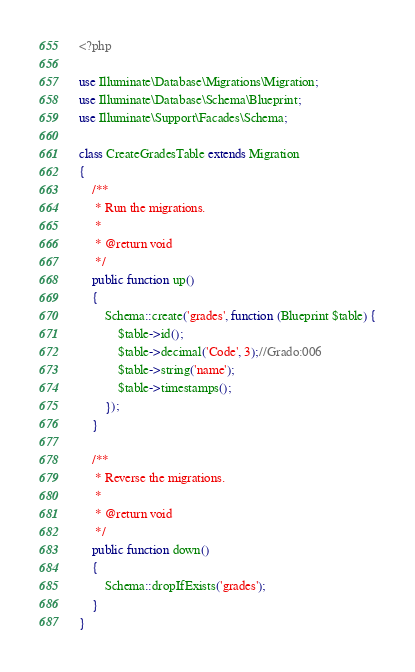Convert code to text. <code><loc_0><loc_0><loc_500><loc_500><_PHP_><?php

use Illuminate\Database\Migrations\Migration;
use Illuminate\Database\Schema\Blueprint;
use Illuminate\Support\Facades\Schema;

class CreateGradesTable extends Migration
{
    /**
     * Run the migrations.
     *
     * @return void
     */
    public function up()
    {
        Schema::create('grades', function (Blueprint $table) {
            $table->id();
            $table->decimal('Code', 3);//Grado:006
            $table->string('name');            
            $table->timestamps();
        });
    }

    /**
     * Reverse the migrations.
     *
     * @return void
     */
    public function down()
    {
        Schema::dropIfExists('grades');
    }
}
</code> 